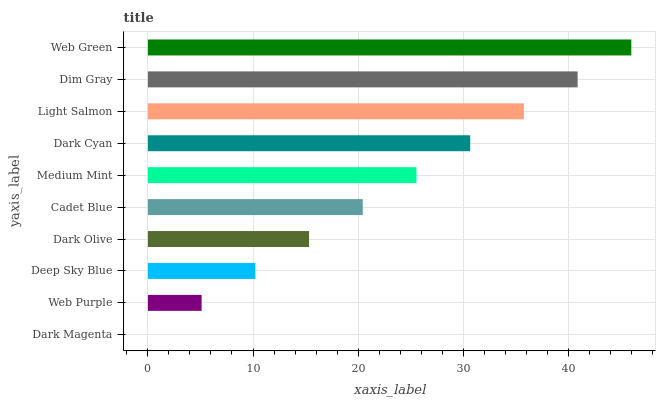Is Dark Magenta the minimum?
Answer yes or no. Yes. Is Web Green the maximum?
Answer yes or no. Yes. Is Web Purple the minimum?
Answer yes or no. No. Is Web Purple the maximum?
Answer yes or no. No. Is Web Purple greater than Dark Magenta?
Answer yes or no. Yes. Is Dark Magenta less than Web Purple?
Answer yes or no. Yes. Is Dark Magenta greater than Web Purple?
Answer yes or no. No. Is Web Purple less than Dark Magenta?
Answer yes or no. No. Is Medium Mint the high median?
Answer yes or no. Yes. Is Cadet Blue the low median?
Answer yes or no. Yes. Is Deep Sky Blue the high median?
Answer yes or no. No. Is Dark Olive the low median?
Answer yes or no. No. 